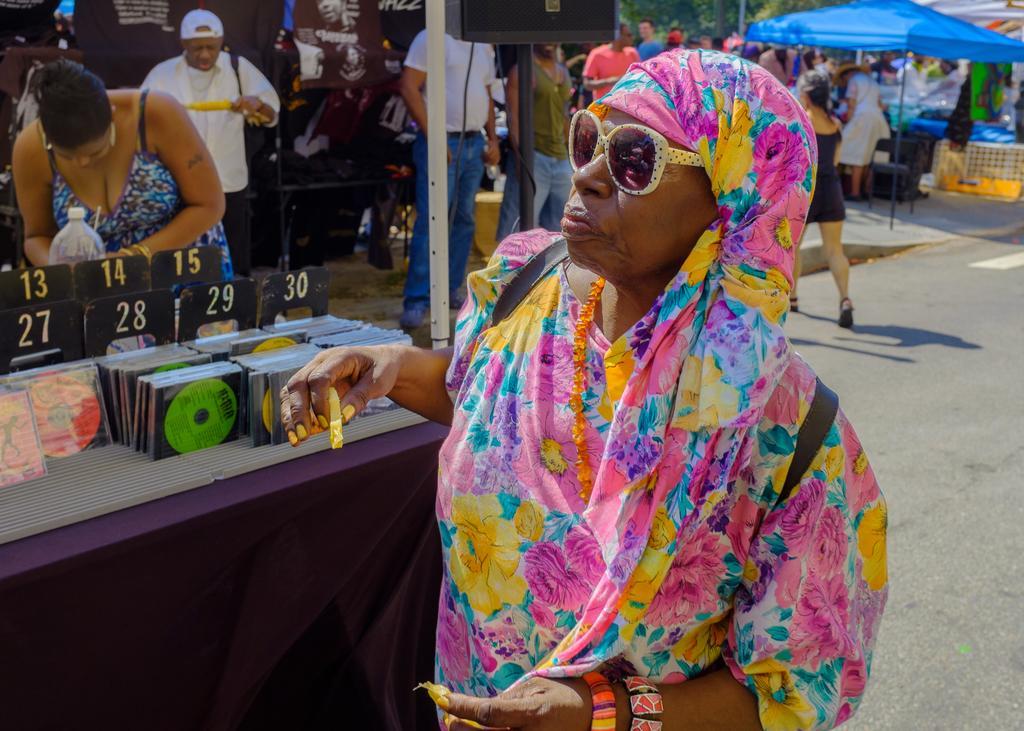How would you summarize this image in a sentence or two? In this picture we can see a woman wearing a colorful saree and spectacles. In the background, we can see many people standing in front of the stalls. 